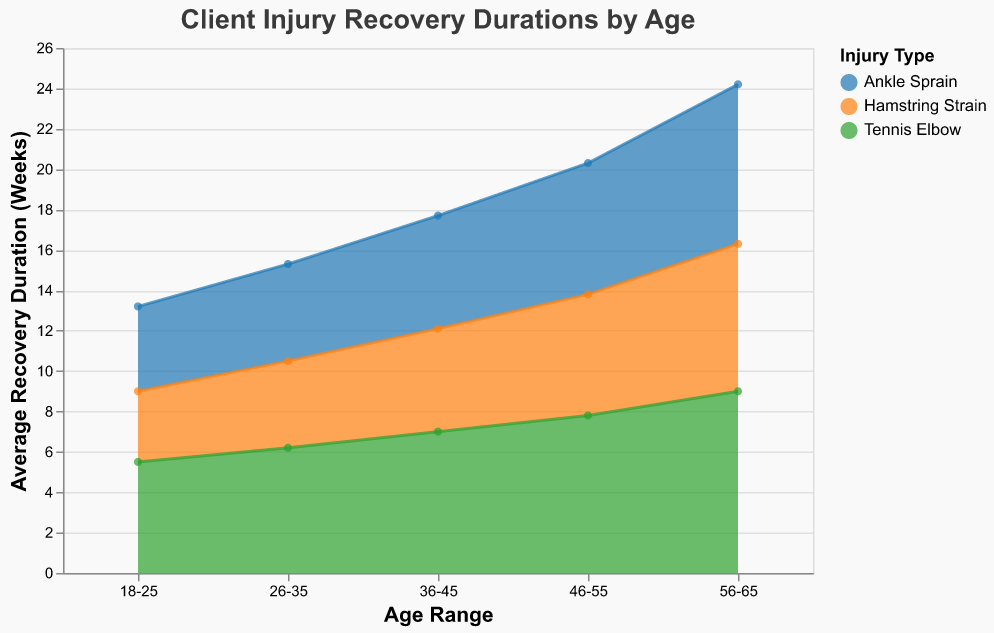What is the title of the chart? The title of the chart is displayed at the top and is labeled as "Client Injury Recovery Durations by Age".
Answer: Client Injury Recovery Durations by Age Which injury type has the longest average recovery duration for clients aged 18-25? By looking at the 18-25 age range on the x-axis and comparing the average recovery duration for each injury type, we see that Tennis Elbow has the longest average recovery duration at 5.5 weeks.
Answer: Tennis Elbow What is the total number of clients who had ankle sprains in the age range 36-45? The tooltip information shows that the number of clients with ankle sprains for the age range 36-45 is 14.
Answer: 14 How does the average recovery duration of hamstring strain change as age increases from 18-25 to 56-65? By examining the chart, the average recovery durations for hamstring strain are 3.5 weeks (18-25), 4.3 weeks (26-35), 5.1 weeks (36-45), 6.0 weeks (46-55), and 7.3 weeks (56-65). The recovery duration increases steadily with age.
Answer: Increases steadily with age Compare the recovery duration of Tennis Elbow and Hamstring Strain for clients aged 46-55. By looking at the 46-55 age range on the x-axis, the chart shows that Tennis Elbow has an average recovery duration of 7.8 weeks and Hamstring Strain has 6.0 weeks. Tennis Elbow has a longer recovery duration by 1.8 weeks.
Answer: Tennis Elbow has a longer recovery duration by 1.8 weeks What is the overall trend in recovery durations for ankle sprains across different age ranges? Analyzing the trend for Ankle Sprain on the chart, the average recovery durations are 4.2 weeks (18-25), 4.8 weeks (26-35), 5.6 weeks (36-45), 6.5 weeks (46-55), and 7.9 weeks (56-65). The recovery duration increases with age.
Answer: Increases with age Which age range had the least number of clients with Tennis Elbow? By looking at the tooltip data for each age range, the 56-65 age range had the least number of clients with Tennis Elbow, totaling 4 clients.
Answer: 56-65 What is the difference in average recovery duration between Ankle Sprain for clients aged 26-35 and 56-65? Using the chart, the average recovery duration for Ankle Sprain is 4.8 weeks (26-35) and 7.9 weeks (56-65). The difference is 7.9 - 4.8 = 3.1 weeks.
Answer: 3.1 weeks Which injury type shows the highest average recovery duration in the age range 26-35? Looking at the 26-35 age range on the chart and comparing the data points, Tennis Elbow has the highest average recovery duration at 6.2 weeks.
Answer: Tennis Elbow 